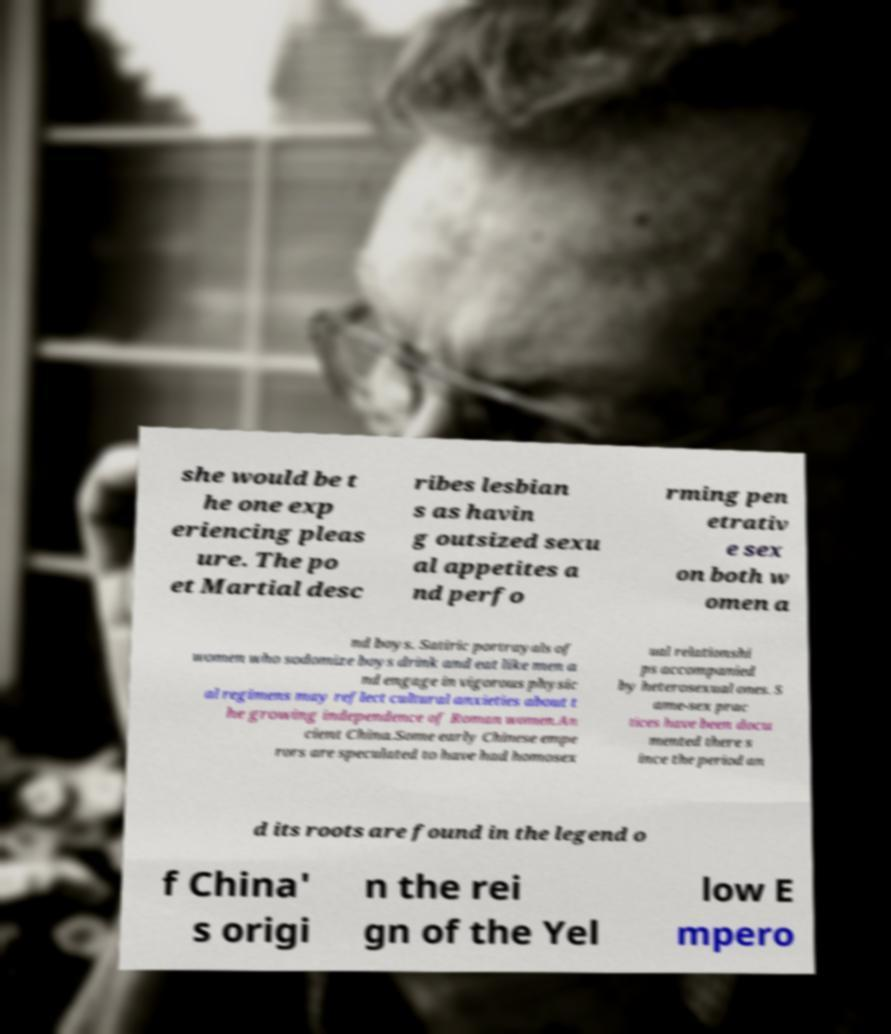Please read and relay the text visible in this image. What does it say? she would be t he one exp eriencing pleas ure. The po et Martial desc ribes lesbian s as havin g outsized sexu al appetites a nd perfo rming pen etrativ e sex on both w omen a nd boys. Satiric portrayals of women who sodomize boys drink and eat like men a nd engage in vigorous physic al regimens may reflect cultural anxieties about t he growing independence of Roman women.An cient China.Some early Chinese empe rors are speculated to have had homosex ual relationshi ps accompanied by heterosexual ones. S ame-sex prac tices have been docu mented there s ince the period an d its roots are found in the legend o f China' s origi n the rei gn of the Yel low E mpero 